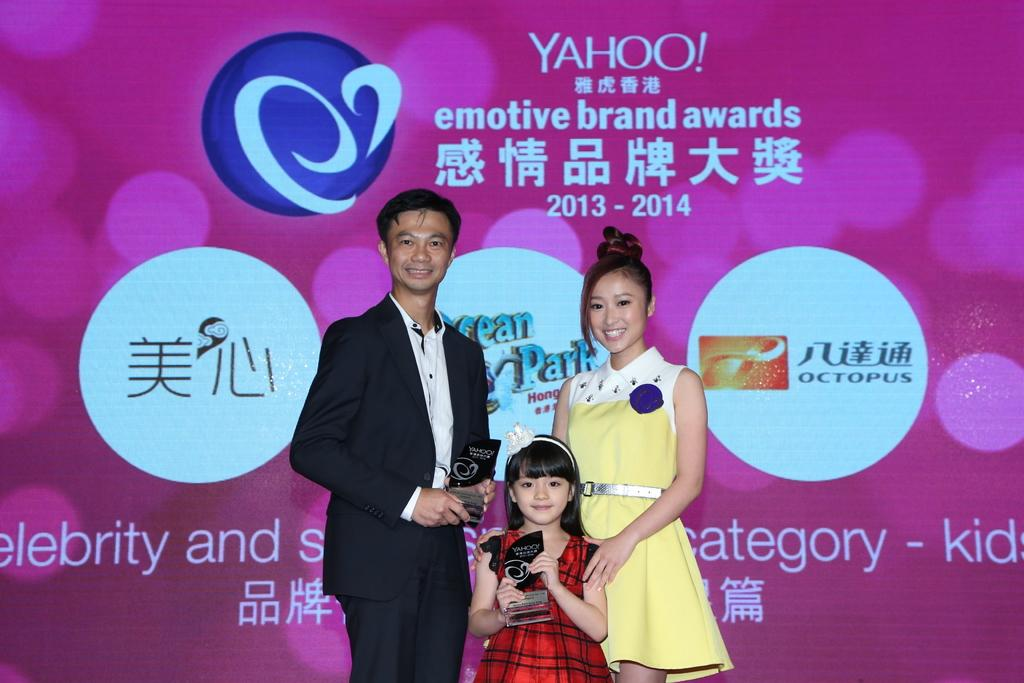How many people are visible in the image? There are three people standing in the foreground of the image. What can be seen in the background of the image? There is a poster in the background of the image. What type of leather is being used to make the bread in the image? There is no bread or leather present in the image. 